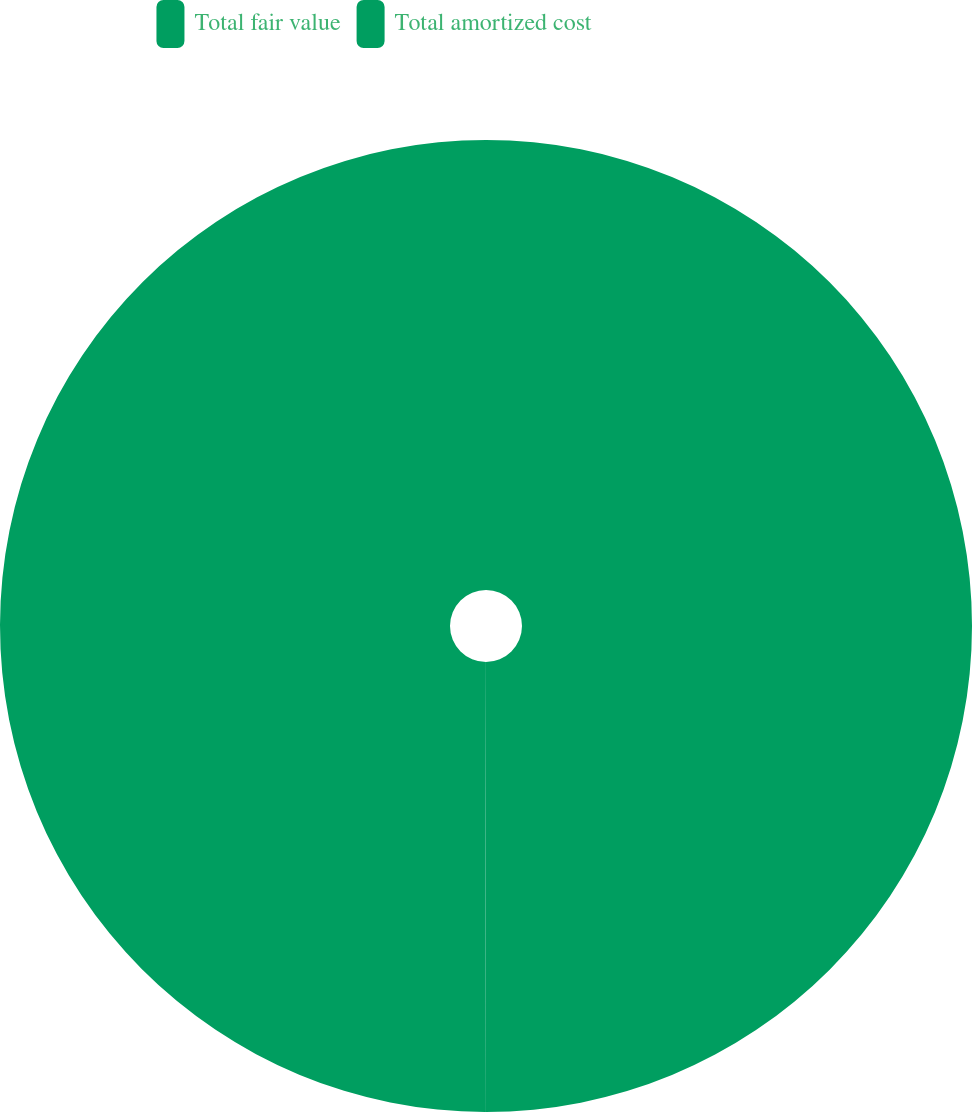Convert chart to OTSL. <chart><loc_0><loc_0><loc_500><loc_500><pie_chart><fcel>Total fair value<fcel>Total amortized cost<nl><fcel>50.03%<fcel>49.97%<nl></chart> 